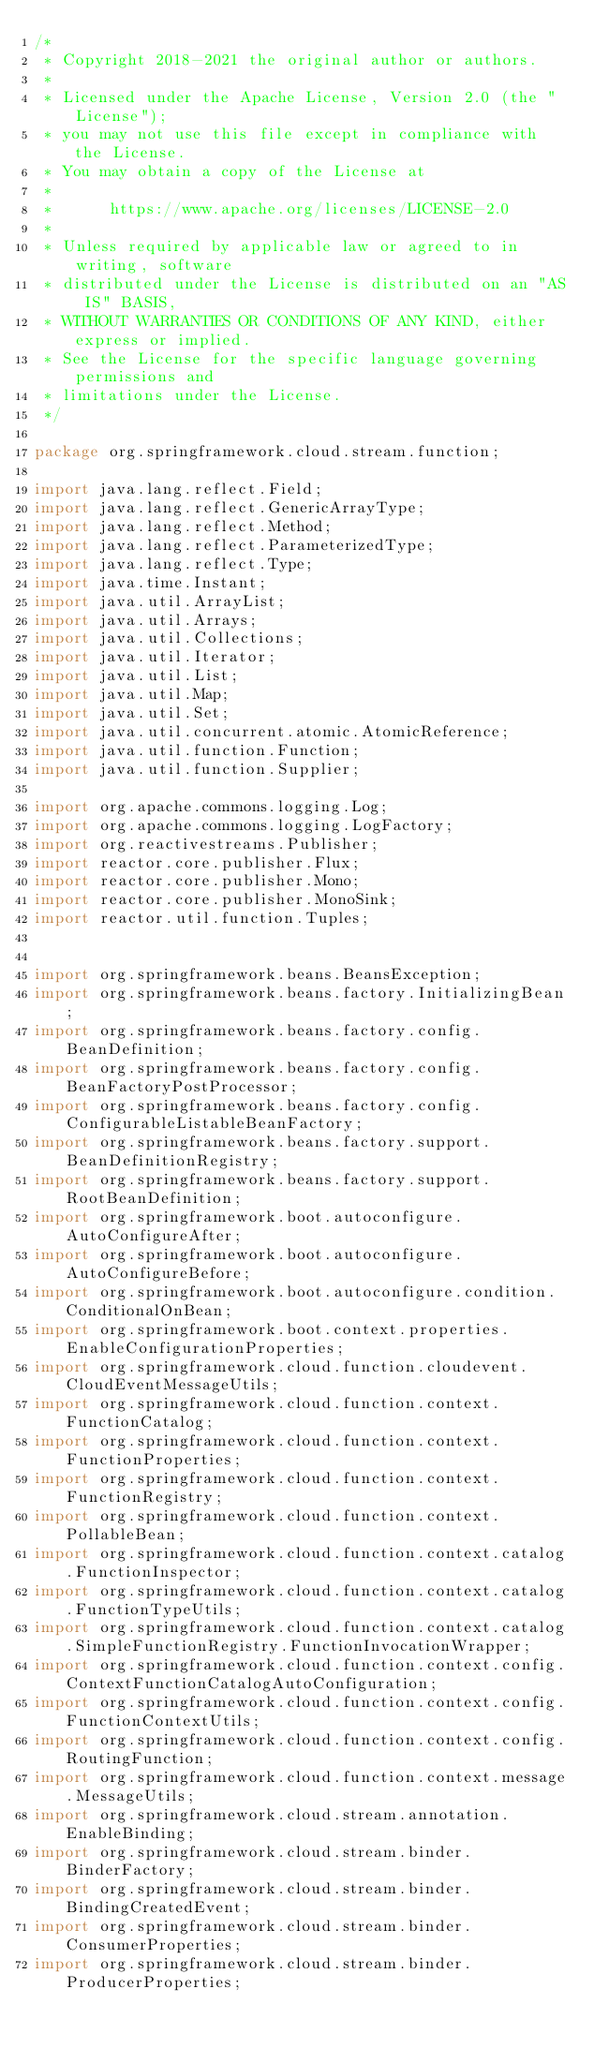<code> <loc_0><loc_0><loc_500><loc_500><_Java_>/*
 * Copyright 2018-2021 the original author or authors.
 *
 * Licensed under the Apache License, Version 2.0 (the "License");
 * you may not use this file except in compliance with the License.
 * You may obtain a copy of the License at
 *
 *      https://www.apache.org/licenses/LICENSE-2.0
 *
 * Unless required by applicable law or agreed to in writing, software
 * distributed under the License is distributed on an "AS IS" BASIS,
 * WITHOUT WARRANTIES OR CONDITIONS OF ANY KIND, either express or implied.
 * See the License for the specific language governing permissions and
 * limitations under the License.
 */

package org.springframework.cloud.stream.function;

import java.lang.reflect.Field;
import java.lang.reflect.GenericArrayType;
import java.lang.reflect.Method;
import java.lang.reflect.ParameterizedType;
import java.lang.reflect.Type;
import java.time.Instant;
import java.util.ArrayList;
import java.util.Arrays;
import java.util.Collections;
import java.util.Iterator;
import java.util.List;
import java.util.Map;
import java.util.Set;
import java.util.concurrent.atomic.AtomicReference;
import java.util.function.Function;
import java.util.function.Supplier;

import org.apache.commons.logging.Log;
import org.apache.commons.logging.LogFactory;
import org.reactivestreams.Publisher;
import reactor.core.publisher.Flux;
import reactor.core.publisher.Mono;
import reactor.core.publisher.MonoSink;
import reactor.util.function.Tuples;


import org.springframework.beans.BeansException;
import org.springframework.beans.factory.InitializingBean;
import org.springframework.beans.factory.config.BeanDefinition;
import org.springframework.beans.factory.config.BeanFactoryPostProcessor;
import org.springframework.beans.factory.config.ConfigurableListableBeanFactory;
import org.springframework.beans.factory.support.BeanDefinitionRegistry;
import org.springframework.beans.factory.support.RootBeanDefinition;
import org.springframework.boot.autoconfigure.AutoConfigureAfter;
import org.springframework.boot.autoconfigure.AutoConfigureBefore;
import org.springframework.boot.autoconfigure.condition.ConditionalOnBean;
import org.springframework.boot.context.properties.EnableConfigurationProperties;
import org.springframework.cloud.function.cloudevent.CloudEventMessageUtils;
import org.springframework.cloud.function.context.FunctionCatalog;
import org.springframework.cloud.function.context.FunctionProperties;
import org.springframework.cloud.function.context.FunctionRegistry;
import org.springframework.cloud.function.context.PollableBean;
import org.springframework.cloud.function.context.catalog.FunctionInspector;
import org.springframework.cloud.function.context.catalog.FunctionTypeUtils;
import org.springframework.cloud.function.context.catalog.SimpleFunctionRegistry.FunctionInvocationWrapper;
import org.springframework.cloud.function.context.config.ContextFunctionCatalogAutoConfiguration;
import org.springframework.cloud.function.context.config.FunctionContextUtils;
import org.springframework.cloud.function.context.config.RoutingFunction;
import org.springframework.cloud.function.context.message.MessageUtils;
import org.springframework.cloud.stream.annotation.EnableBinding;
import org.springframework.cloud.stream.binder.BinderFactory;
import org.springframework.cloud.stream.binder.BindingCreatedEvent;
import org.springframework.cloud.stream.binder.ConsumerProperties;
import org.springframework.cloud.stream.binder.ProducerProperties;</code> 